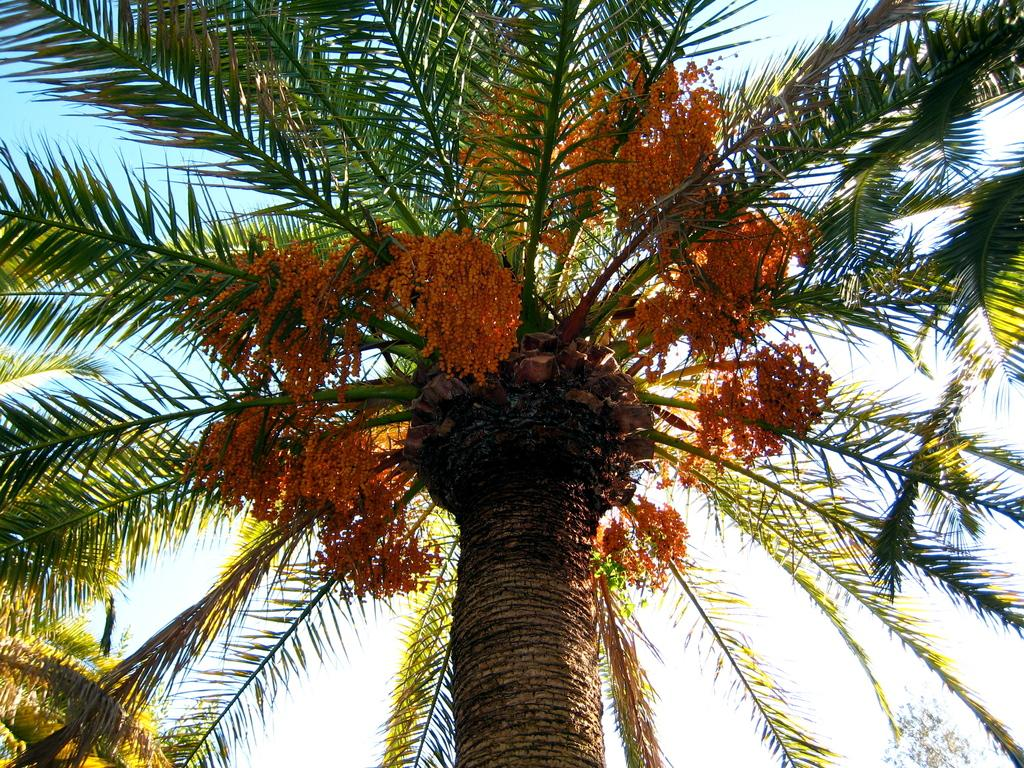What is depicted in the image? There is a picture of a palm tree in the image. Can you describe the appearance of the palm tree? The palm tree has long leaves and yellow flowers. What value does the sheet of paper have in the image? There is no sheet of paper present in the image; it only features a picture of a palm tree. What scientific discoveries can be made from studying the palm tree in the image? The image is not intended for scientific study, and no scientific discoveries can be made from it. 